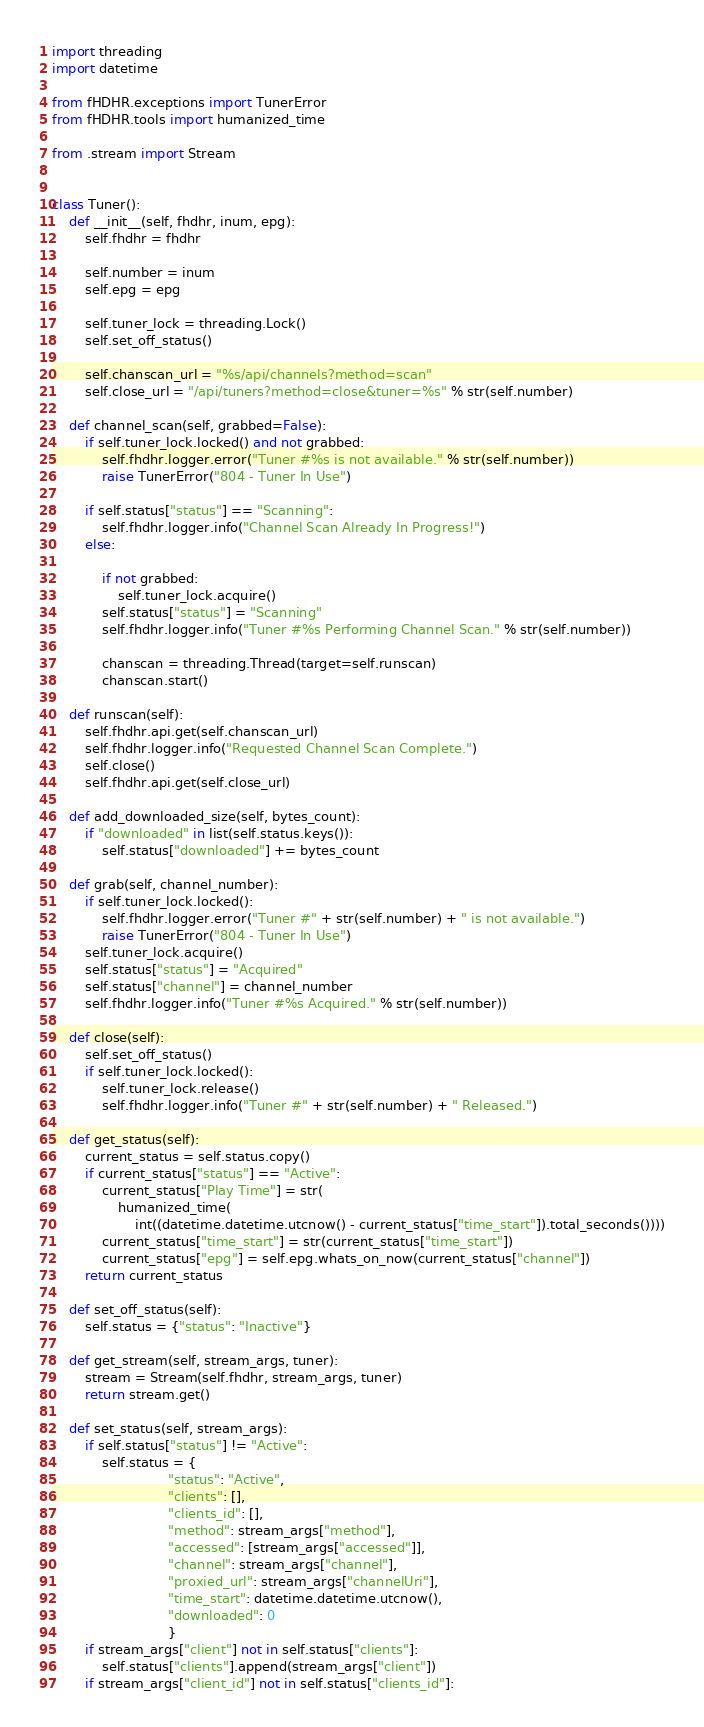<code> <loc_0><loc_0><loc_500><loc_500><_Python_>import threading
import datetime

from fHDHR.exceptions import TunerError
from fHDHR.tools import humanized_time

from .stream import Stream


class Tuner():
    def __init__(self, fhdhr, inum, epg):
        self.fhdhr = fhdhr

        self.number = inum
        self.epg = epg

        self.tuner_lock = threading.Lock()
        self.set_off_status()

        self.chanscan_url = "%s/api/channels?method=scan"
        self.close_url = "/api/tuners?method=close&tuner=%s" % str(self.number)

    def channel_scan(self, grabbed=False):
        if self.tuner_lock.locked() and not grabbed:
            self.fhdhr.logger.error("Tuner #%s is not available." % str(self.number))
            raise TunerError("804 - Tuner In Use")

        if self.status["status"] == "Scanning":
            self.fhdhr.logger.info("Channel Scan Already In Progress!")
        else:

            if not grabbed:
                self.tuner_lock.acquire()
            self.status["status"] = "Scanning"
            self.fhdhr.logger.info("Tuner #%s Performing Channel Scan." % str(self.number))

            chanscan = threading.Thread(target=self.runscan)
            chanscan.start()

    def runscan(self):
        self.fhdhr.api.get(self.chanscan_url)
        self.fhdhr.logger.info("Requested Channel Scan Complete.")
        self.close()
        self.fhdhr.api.get(self.close_url)

    def add_downloaded_size(self, bytes_count):
        if "downloaded" in list(self.status.keys()):
            self.status["downloaded"] += bytes_count

    def grab(self, channel_number):
        if self.tuner_lock.locked():
            self.fhdhr.logger.error("Tuner #" + str(self.number) + " is not available.")
            raise TunerError("804 - Tuner In Use")
        self.tuner_lock.acquire()
        self.status["status"] = "Acquired"
        self.status["channel"] = channel_number
        self.fhdhr.logger.info("Tuner #%s Acquired." % str(self.number))

    def close(self):
        self.set_off_status()
        if self.tuner_lock.locked():
            self.tuner_lock.release()
            self.fhdhr.logger.info("Tuner #" + str(self.number) + " Released.")

    def get_status(self):
        current_status = self.status.copy()
        if current_status["status"] == "Active":
            current_status["Play Time"] = str(
                humanized_time(
                    int((datetime.datetime.utcnow() - current_status["time_start"]).total_seconds())))
            current_status["time_start"] = str(current_status["time_start"])
            current_status["epg"] = self.epg.whats_on_now(current_status["channel"])
        return current_status

    def set_off_status(self):
        self.status = {"status": "Inactive"}

    def get_stream(self, stream_args, tuner):
        stream = Stream(self.fhdhr, stream_args, tuner)
        return stream.get()

    def set_status(self, stream_args):
        if self.status["status"] != "Active":
            self.status = {
                            "status": "Active",
                            "clients": [],
                            "clients_id": [],
                            "method": stream_args["method"],
                            "accessed": [stream_args["accessed"]],
                            "channel": stream_args["channel"],
                            "proxied_url": stream_args["channelUri"],
                            "time_start": datetime.datetime.utcnow(),
                            "downloaded": 0
                            }
        if stream_args["client"] not in self.status["clients"]:
            self.status["clients"].append(stream_args["client"])
        if stream_args["client_id"] not in self.status["clients_id"]:</code> 